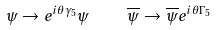Convert formula to latex. <formula><loc_0><loc_0><loc_500><loc_500>\psi \rightarrow e ^ { i \theta \gamma _ { 5 } } \psi \quad \overline { \psi } \rightarrow \overline { \psi } e ^ { i \theta \Gamma _ { 5 } }</formula> 